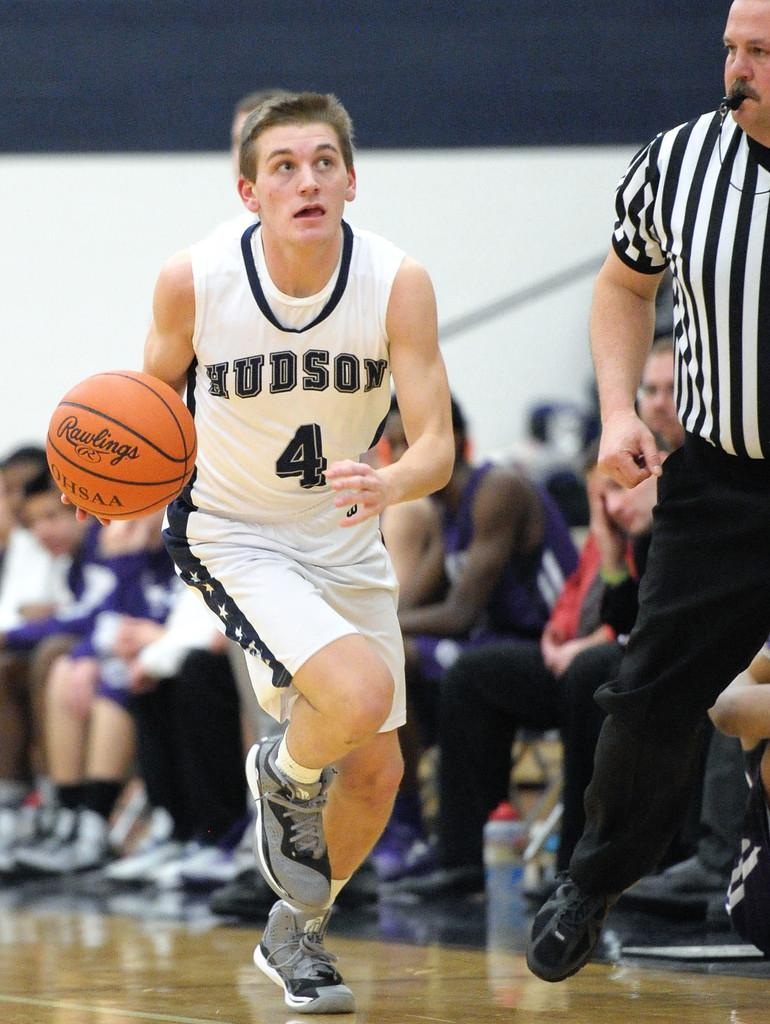Provide a one-sentence caption for the provided image. kid playing basetball from hudson school number 4. 